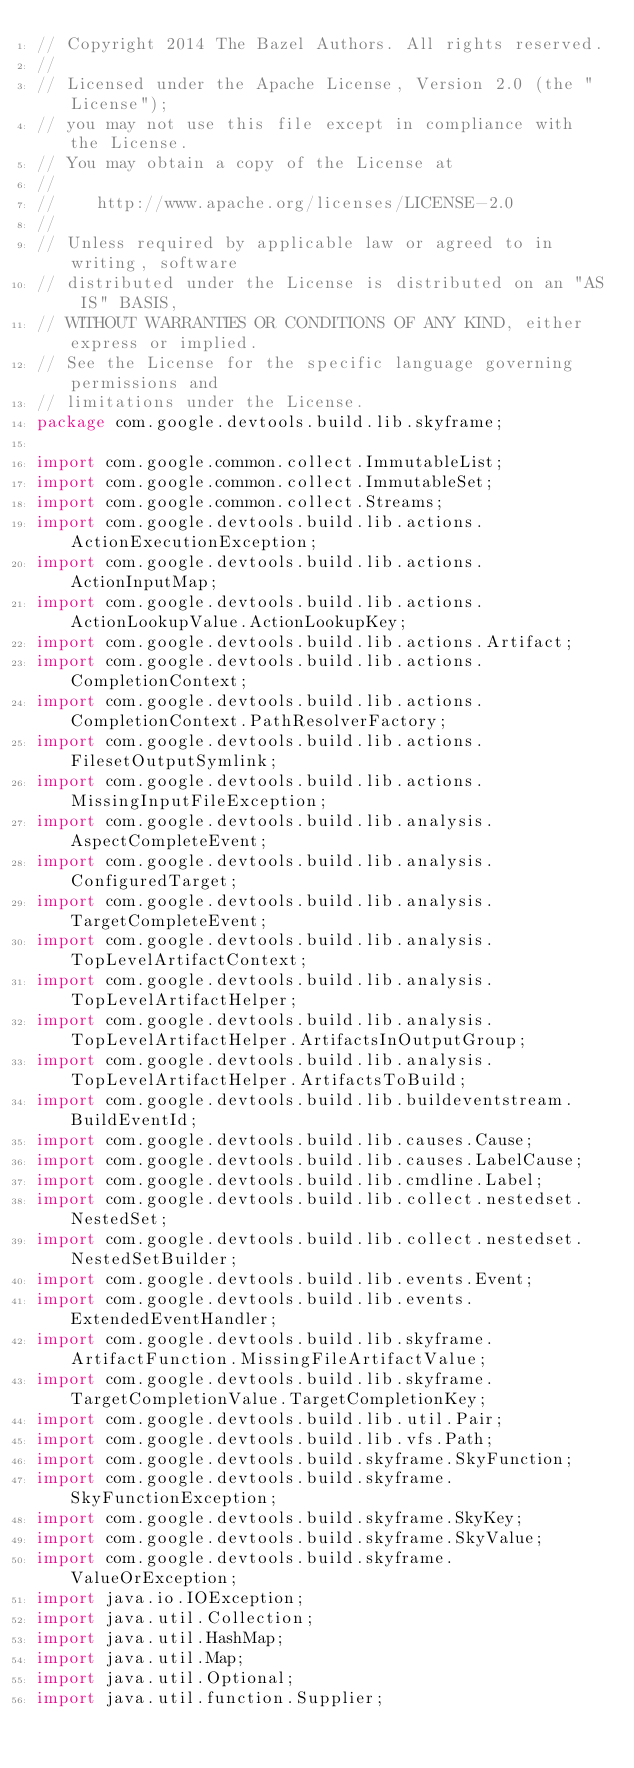Convert code to text. <code><loc_0><loc_0><loc_500><loc_500><_Java_>// Copyright 2014 The Bazel Authors. All rights reserved.
//
// Licensed under the Apache License, Version 2.0 (the "License");
// you may not use this file except in compliance with the License.
// You may obtain a copy of the License at
//
//    http://www.apache.org/licenses/LICENSE-2.0
//
// Unless required by applicable law or agreed to in writing, software
// distributed under the License is distributed on an "AS IS" BASIS,
// WITHOUT WARRANTIES OR CONDITIONS OF ANY KIND, either express or implied.
// See the License for the specific language governing permissions and
// limitations under the License.
package com.google.devtools.build.lib.skyframe;

import com.google.common.collect.ImmutableList;
import com.google.common.collect.ImmutableSet;
import com.google.common.collect.Streams;
import com.google.devtools.build.lib.actions.ActionExecutionException;
import com.google.devtools.build.lib.actions.ActionInputMap;
import com.google.devtools.build.lib.actions.ActionLookupValue.ActionLookupKey;
import com.google.devtools.build.lib.actions.Artifact;
import com.google.devtools.build.lib.actions.CompletionContext;
import com.google.devtools.build.lib.actions.CompletionContext.PathResolverFactory;
import com.google.devtools.build.lib.actions.FilesetOutputSymlink;
import com.google.devtools.build.lib.actions.MissingInputFileException;
import com.google.devtools.build.lib.analysis.AspectCompleteEvent;
import com.google.devtools.build.lib.analysis.ConfiguredTarget;
import com.google.devtools.build.lib.analysis.TargetCompleteEvent;
import com.google.devtools.build.lib.analysis.TopLevelArtifactContext;
import com.google.devtools.build.lib.analysis.TopLevelArtifactHelper;
import com.google.devtools.build.lib.analysis.TopLevelArtifactHelper.ArtifactsInOutputGroup;
import com.google.devtools.build.lib.analysis.TopLevelArtifactHelper.ArtifactsToBuild;
import com.google.devtools.build.lib.buildeventstream.BuildEventId;
import com.google.devtools.build.lib.causes.Cause;
import com.google.devtools.build.lib.causes.LabelCause;
import com.google.devtools.build.lib.cmdline.Label;
import com.google.devtools.build.lib.collect.nestedset.NestedSet;
import com.google.devtools.build.lib.collect.nestedset.NestedSetBuilder;
import com.google.devtools.build.lib.events.Event;
import com.google.devtools.build.lib.events.ExtendedEventHandler;
import com.google.devtools.build.lib.skyframe.ArtifactFunction.MissingFileArtifactValue;
import com.google.devtools.build.lib.skyframe.TargetCompletionValue.TargetCompletionKey;
import com.google.devtools.build.lib.util.Pair;
import com.google.devtools.build.lib.vfs.Path;
import com.google.devtools.build.skyframe.SkyFunction;
import com.google.devtools.build.skyframe.SkyFunctionException;
import com.google.devtools.build.skyframe.SkyKey;
import com.google.devtools.build.skyframe.SkyValue;
import com.google.devtools.build.skyframe.ValueOrException;
import java.io.IOException;
import java.util.Collection;
import java.util.HashMap;
import java.util.Map;
import java.util.Optional;
import java.util.function.Supplier;</code> 